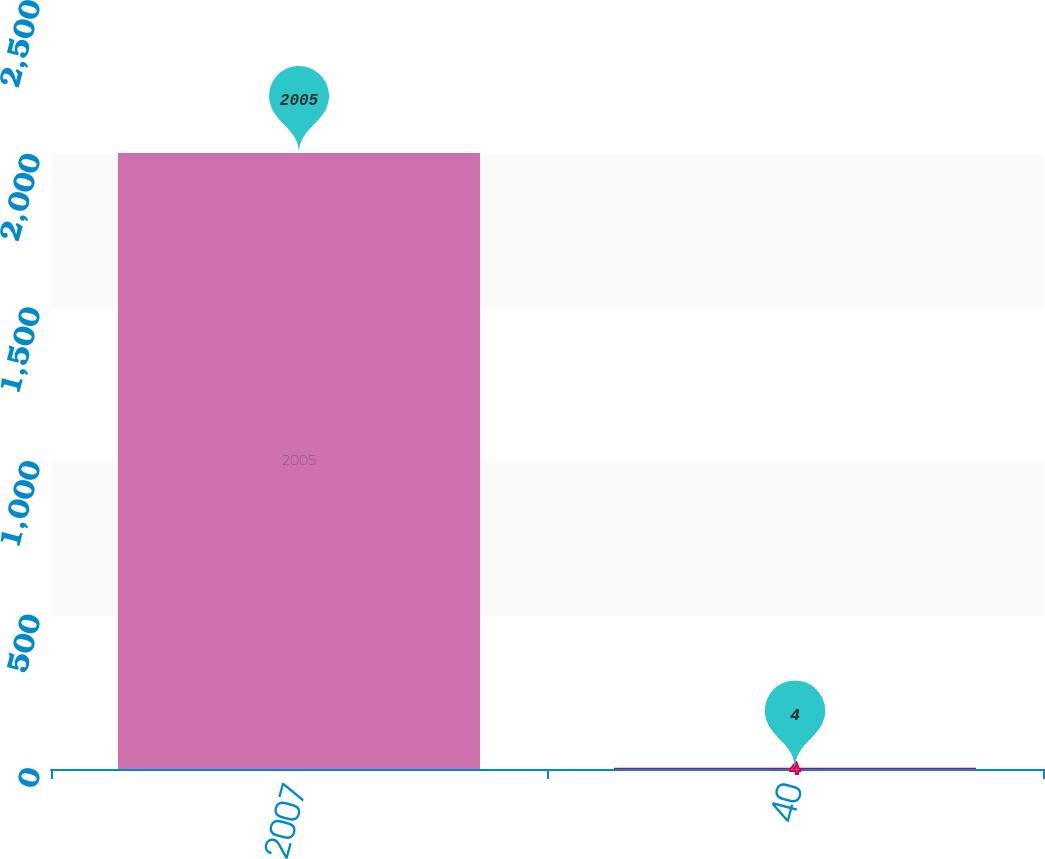<chart> <loc_0><loc_0><loc_500><loc_500><bar_chart><fcel>2007<fcel>40<nl><fcel>2005<fcel>4<nl></chart> 